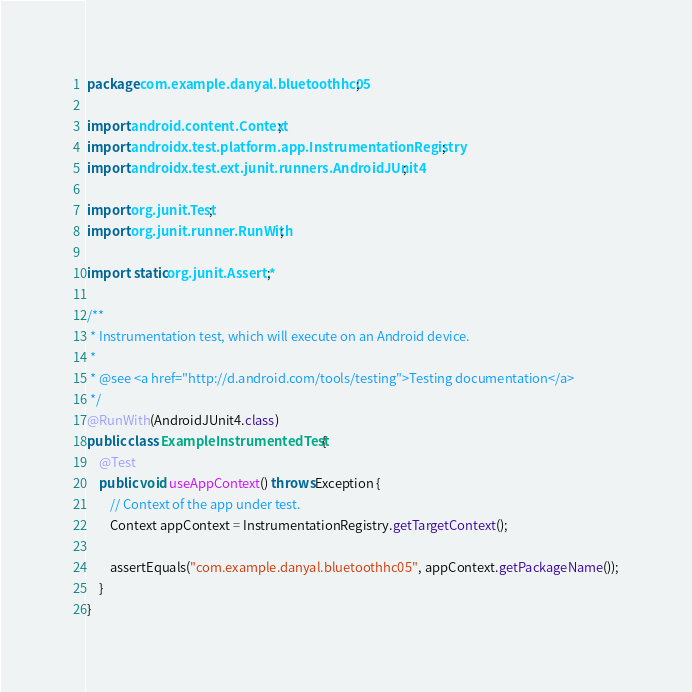Convert code to text. <code><loc_0><loc_0><loc_500><loc_500><_Java_>package com.example.danyal.bluetoothhc05;

import android.content.Context;
import androidx.test.platform.app.InstrumentationRegistry;
import androidx.test.ext.junit.runners.AndroidJUnit4;

import org.junit.Test;
import org.junit.runner.RunWith;

import static org.junit.Assert.*;

/**
 * Instrumentation test, which will execute on an Android device.
 *
 * @see <a href="http://d.android.com/tools/testing">Testing documentation</a>
 */
@RunWith(AndroidJUnit4.class)
public class ExampleInstrumentedTest {
    @Test
    public void useAppContext() throws Exception {
        // Context of the app under test.
        Context appContext = InstrumentationRegistry.getTargetContext();

        assertEquals("com.example.danyal.bluetoothhc05", appContext.getPackageName());
    }
}
</code> 